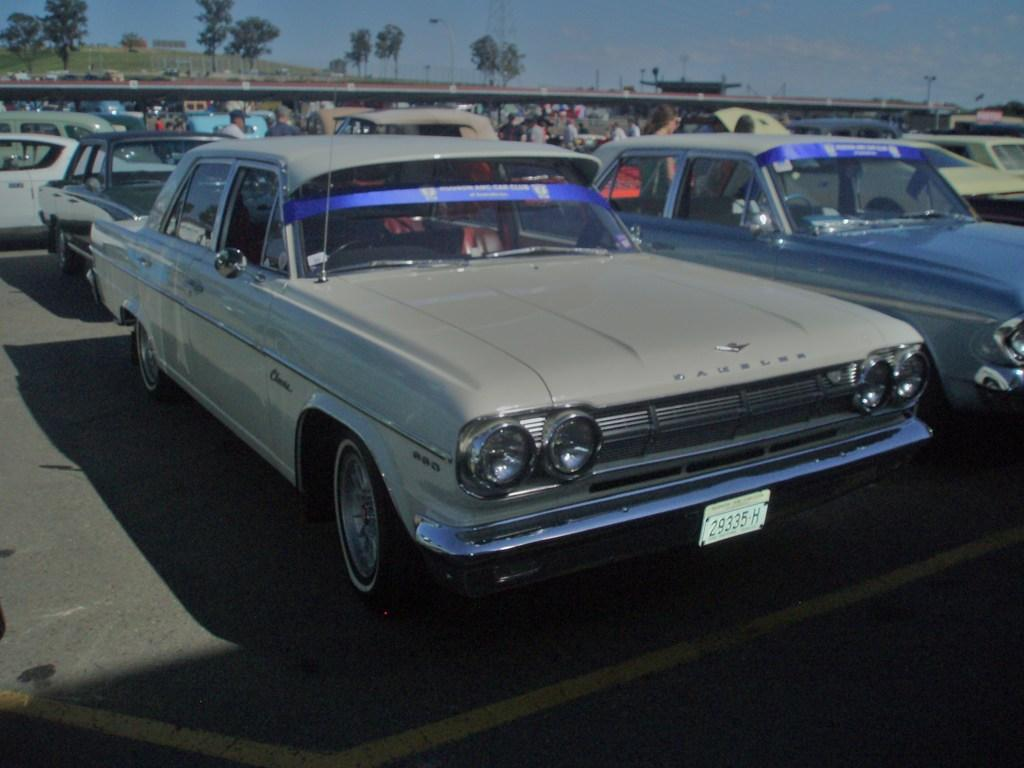<image>
Describe the image concisely. A row of old fashioned cars in a parking lot and the front plate says 29335H. 